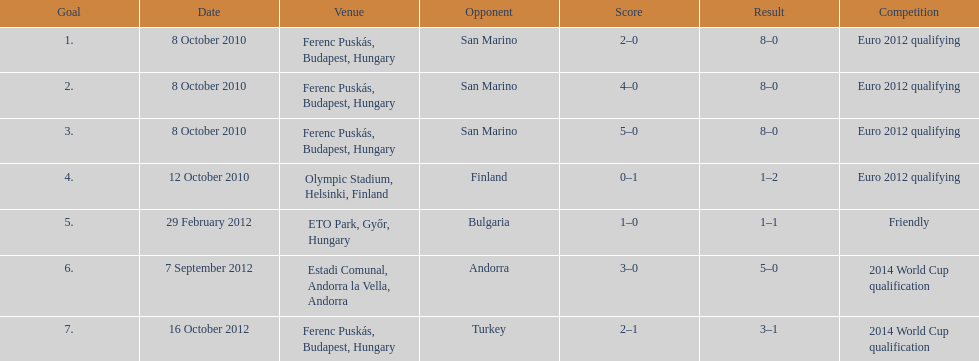Parse the table in full. {'header': ['Goal', 'Date', 'Venue', 'Opponent', 'Score', 'Result', 'Competition'], 'rows': [['1.', '8 October 2010', 'Ferenc Puskás, Budapest, Hungary', 'San Marino', '2–0', '8–0', 'Euro 2012 qualifying'], ['2.', '8 October 2010', 'Ferenc Puskás, Budapest, Hungary', 'San Marino', '4–0', '8–0', 'Euro 2012 qualifying'], ['3.', '8 October 2010', 'Ferenc Puskás, Budapest, Hungary', 'San Marino', '5–0', '8–0', 'Euro 2012 qualifying'], ['4.', '12 October 2010', 'Olympic Stadium, Helsinki, Finland', 'Finland', '0–1', '1–2', 'Euro 2012 qualifying'], ['5.', '29 February 2012', 'ETO Park, Győr, Hungary', 'Bulgaria', '1–0', '1–1', 'Friendly'], ['6.', '7 September 2012', 'Estadi Comunal, Andorra la Vella, Andorra', 'Andorra', '3–0', '5–0', '2014 World Cup qualification'], ['7.', '16 October 2012', 'Ferenc Puskás, Budapest, Hungary', 'Turkey', '2–1', '3–1', '2014 World Cup qualification']]} In what year was szalai's first international goal? 2010. 